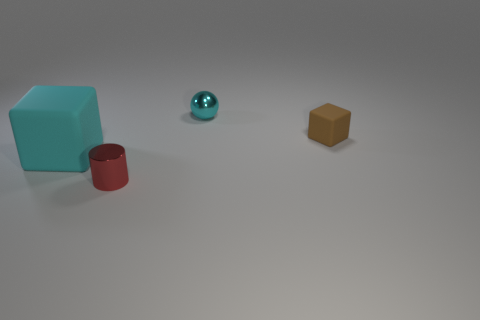How many other objects are the same color as the metallic sphere?
Make the answer very short. 1. How many other objects are there of the same material as the cyan cube?
Your answer should be compact. 1. There is a brown block that is the same size as the cyan sphere; what is its material?
Provide a succinct answer. Rubber. How many green objects are tiny balls or big metallic objects?
Your response must be concise. 0. The tiny object that is in front of the cyan metallic sphere and behind the large block is what color?
Offer a terse response. Brown. Is the object that is left of the red metal object made of the same material as the object in front of the big matte object?
Make the answer very short. No. Are there more metallic cylinders in front of the tiny red metallic thing than spheres that are to the right of the cyan shiny sphere?
Your answer should be compact. No. What shape is the matte object that is the same size as the red shiny thing?
Make the answer very short. Cube. How many things are cyan matte cubes or rubber cubes that are left of the ball?
Offer a terse response. 1. Does the tiny matte thing have the same color as the tiny metallic sphere?
Provide a succinct answer. No. 